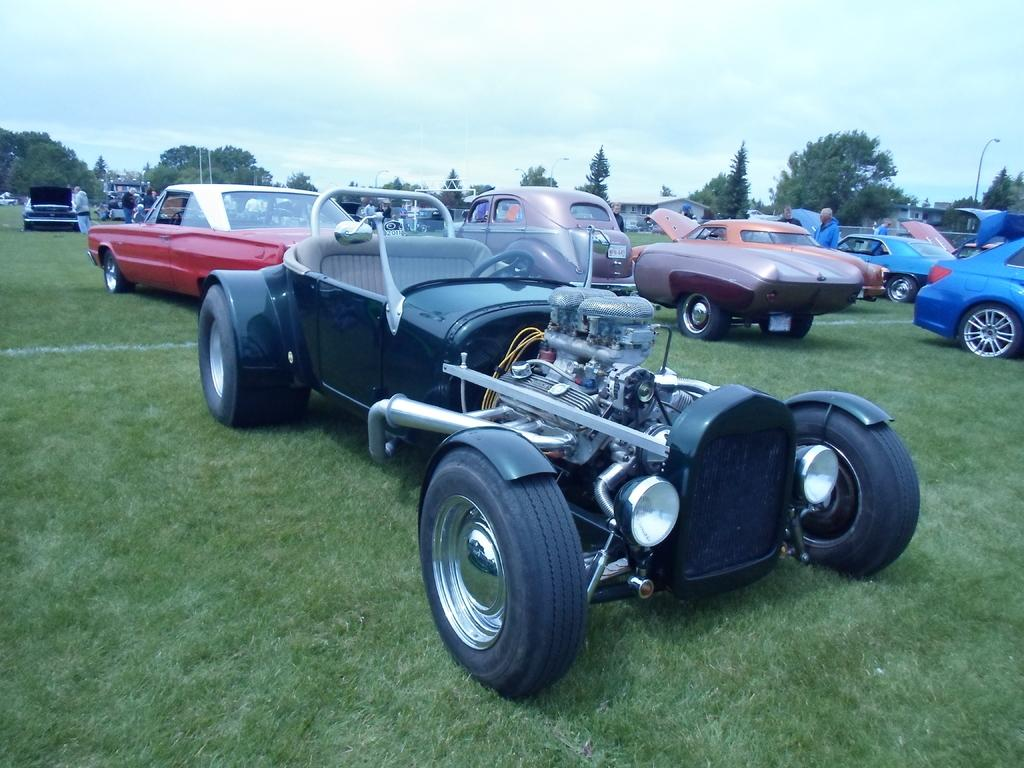What type of vehicles are in the image? There are cars in the image. Where are the cars located? The cars are on a grassland. What else can be seen in the image besides the cars? There are people standing near the cars, trees in the background, houses in the background, and the sky is visible in the background. What type of bone can be seen in the image? There is no bone present in the image. What type of clouds can be seen in the image? The provided facts do not mention clouds; only the sky is mentioned as being visible in the background. 